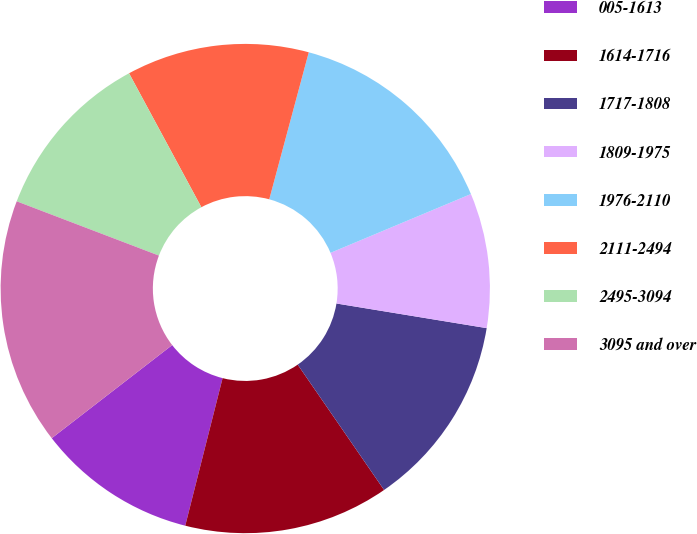Convert chart. <chart><loc_0><loc_0><loc_500><loc_500><pie_chart><fcel>005-1613<fcel>1614-1716<fcel>1717-1808<fcel>1809-1975<fcel>1976-2110<fcel>2111-2494<fcel>2495-3094<fcel>3095 and over<nl><fcel>10.58%<fcel>13.55%<fcel>12.81%<fcel>8.9%<fcel>14.51%<fcel>12.06%<fcel>11.32%<fcel>16.28%<nl></chart> 